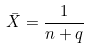<formula> <loc_0><loc_0><loc_500><loc_500>\bar { X } = \frac { 1 } { n + q }</formula> 